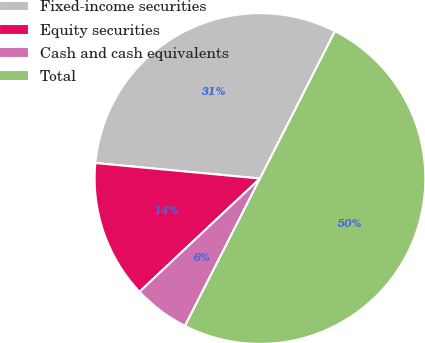Convert chart. <chart><loc_0><loc_0><loc_500><loc_500><pie_chart><fcel>Fixed-income securities<fcel>Equity securities<fcel>Cash and cash equivalents<fcel>Total<nl><fcel>31.0%<fcel>13.5%<fcel>5.5%<fcel>50.0%<nl></chart> 